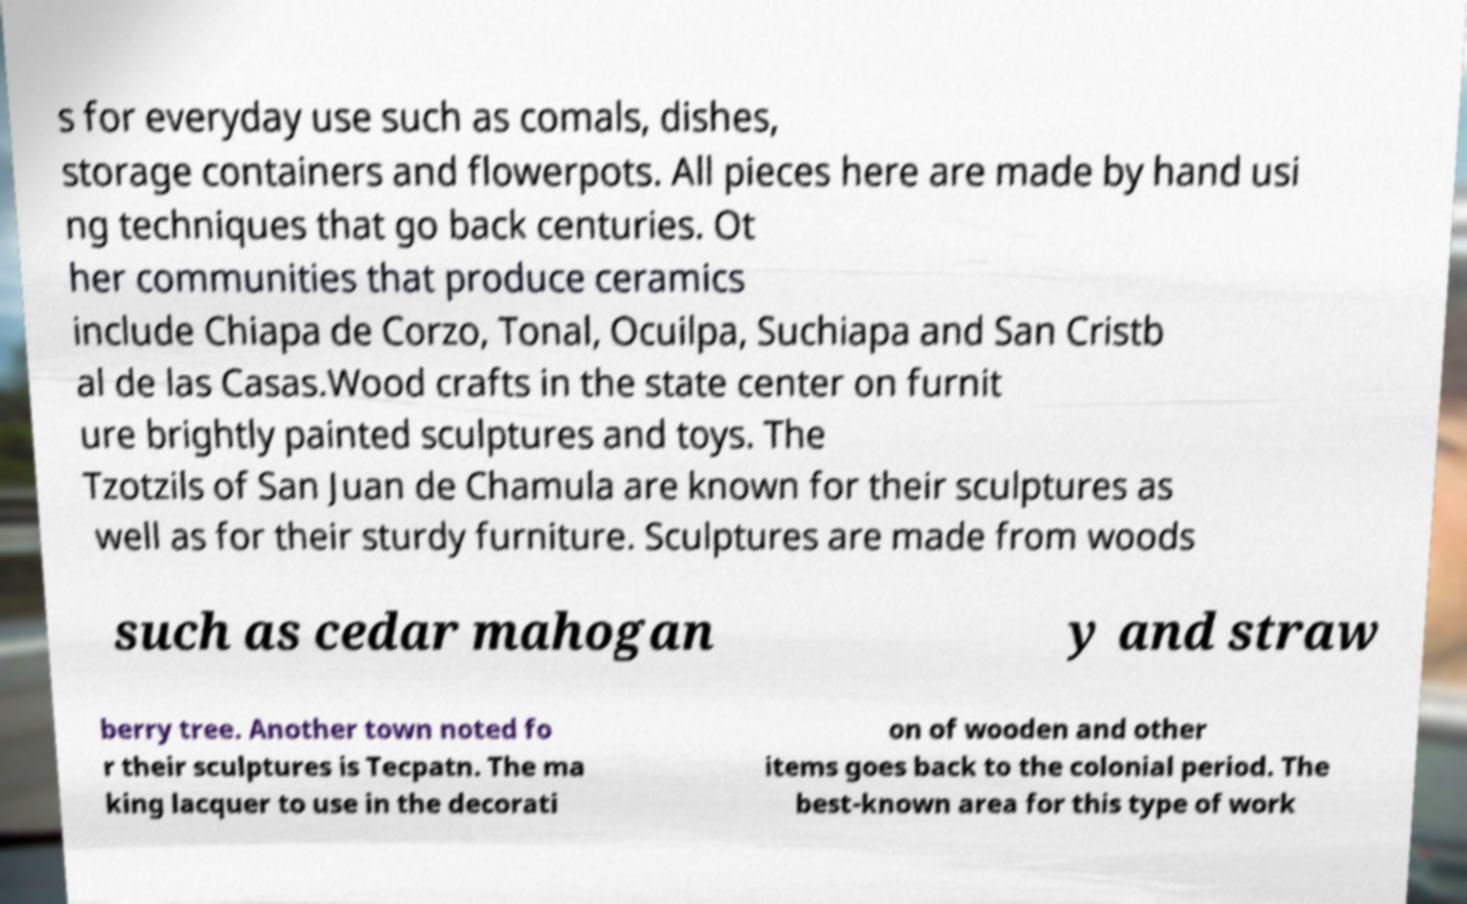What messages or text are displayed in this image? I need them in a readable, typed format. s for everyday use such as comals, dishes, storage containers and flowerpots. All pieces here are made by hand usi ng techniques that go back centuries. Ot her communities that produce ceramics include Chiapa de Corzo, Tonal, Ocuilpa, Suchiapa and San Cristb al de las Casas.Wood crafts in the state center on furnit ure brightly painted sculptures and toys. The Tzotzils of San Juan de Chamula are known for their sculptures as well as for their sturdy furniture. Sculptures are made from woods such as cedar mahogan y and straw berry tree. Another town noted fo r their sculptures is Tecpatn. The ma king lacquer to use in the decorati on of wooden and other items goes back to the colonial period. The best-known area for this type of work 